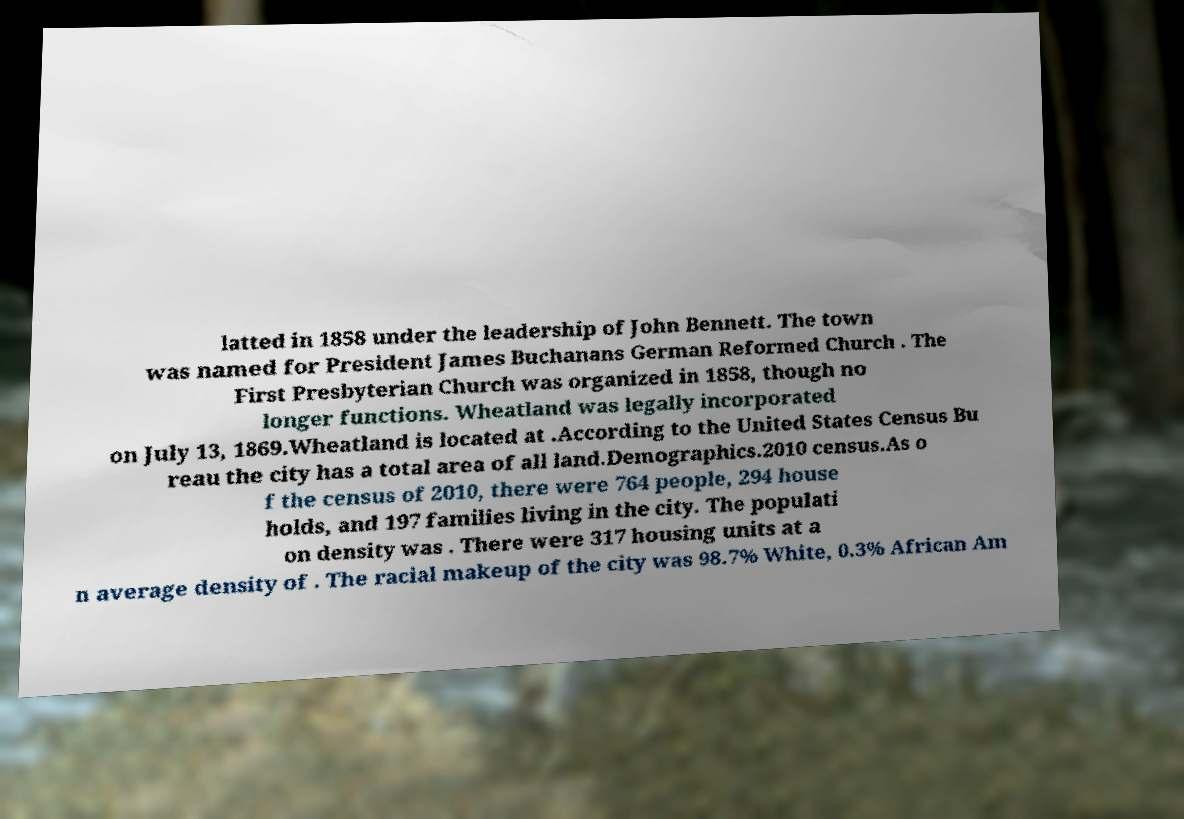I need the written content from this picture converted into text. Can you do that? latted in 1858 under the leadership of John Bennett. The town was named for President James Buchanans German Reformed Church . The First Presbyterian Church was organized in 1858, though no longer functions. Wheatland was legally incorporated on July 13, 1869.Wheatland is located at .According to the United States Census Bu reau the city has a total area of all land.Demographics.2010 census.As o f the census of 2010, there were 764 people, 294 house holds, and 197 families living in the city. The populati on density was . There were 317 housing units at a n average density of . The racial makeup of the city was 98.7% White, 0.3% African Am 